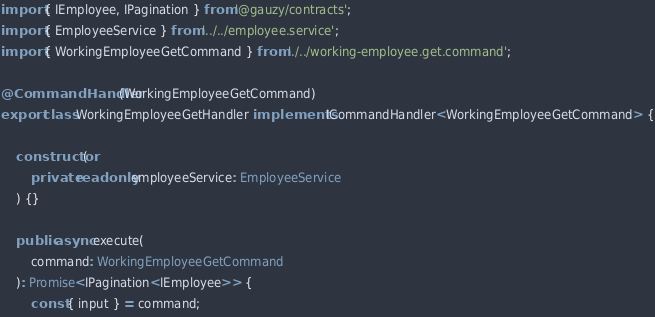<code> <loc_0><loc_0><loc_500><loc_500><_TypeScript_>import { IEmployee, IPagination } from '@gauzy/contracts';
import { EmployeeService } from '../../employee.service';
import { WorkingEmployeeGetCommand } from './../working-employee.get.command';

@CommandHandler(WorkingEmployeeGetCommand)
export class WorkingEmployeeGetHandler implements ICommandHandler<WorkingEmployeeGetCommand> {

	constructor(
		private readonly employeeService: EmployeeService
	) {}

	public async execute(
		command: WorkingEmployeeGetCommand
	): Promise<IPagination<IEmployee>> {
		const { input } = command;</code> 